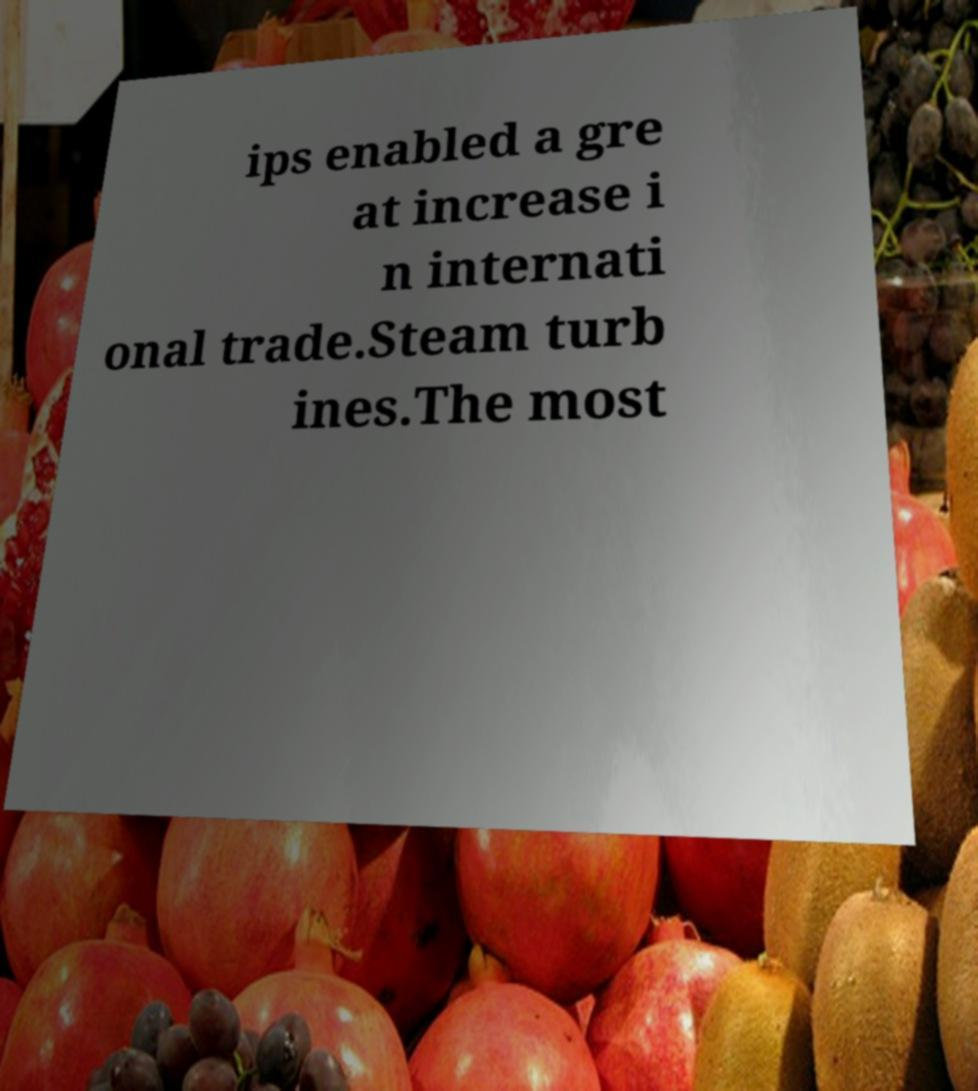For documentation purposes, I need the text within this image transcribed. Could you provide that? ips enabled a gre at increase i n internati onal trade.Steam turb ines.The most 